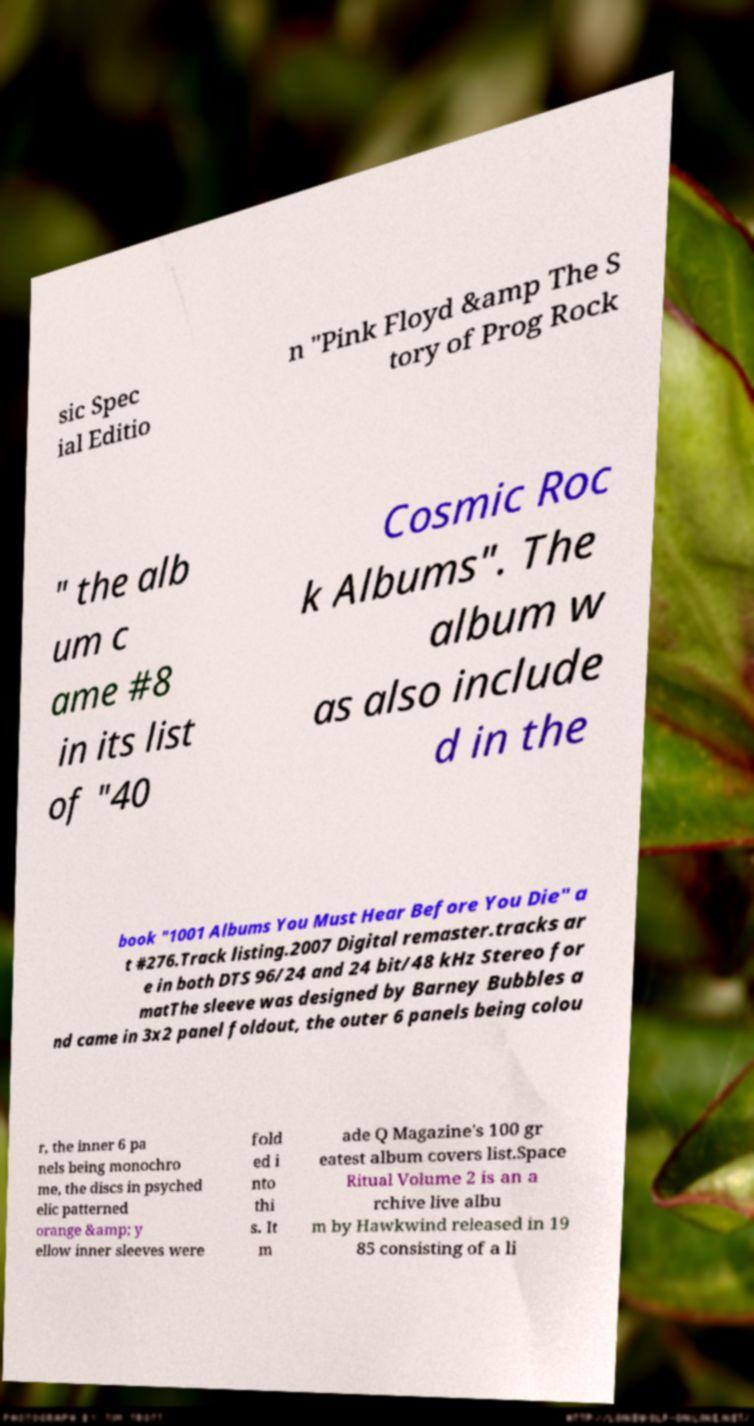Please identify and transcribe the text found in this image. sic Spec ial Editio n "Pink Floyd &amp The S tory of Prog Rock " the alb um c ame #8 in its list of "40 Cosmic Roc k Albums". The album w as also include d in the book "1001 Albums You Must Hear Before You Die" a t #276.Track listing.2007 Digital remaster.tracks ar e in both DTS 96/24 and 24 bit/48 kHz Stereo for matThe sleeve was designed by Barney Bubbles a nd came in 3x2 panel foldout, the outer 6 panels being colou r, the inner 6 pa nels being monochro me, the discs in psyched elic patterned orange &amp; y ellow inner sleeves were fold ed i nto thi s. It m ade Q Magazine's 100 gr eatest album covers list.Space Ritual Volume 2 is an a rchive live albu m by Hawkwind released in 19 85 consisting of a li 